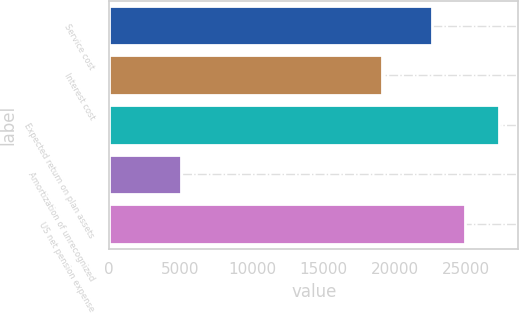Convert chart to OTSL. <chart><loc_0><loc_0><loc_500><loc_500><bar_chart><fcel>Service cost<fcel>Interest cost<fcel>Expected return on plan assets<fcel>Amortization of unrecognized<fcel>US net pension expense<nl><fcel>22583<fcel>19072<fcel>27284.8<fcel>4999<fcel>24933.9<nl></chart> 